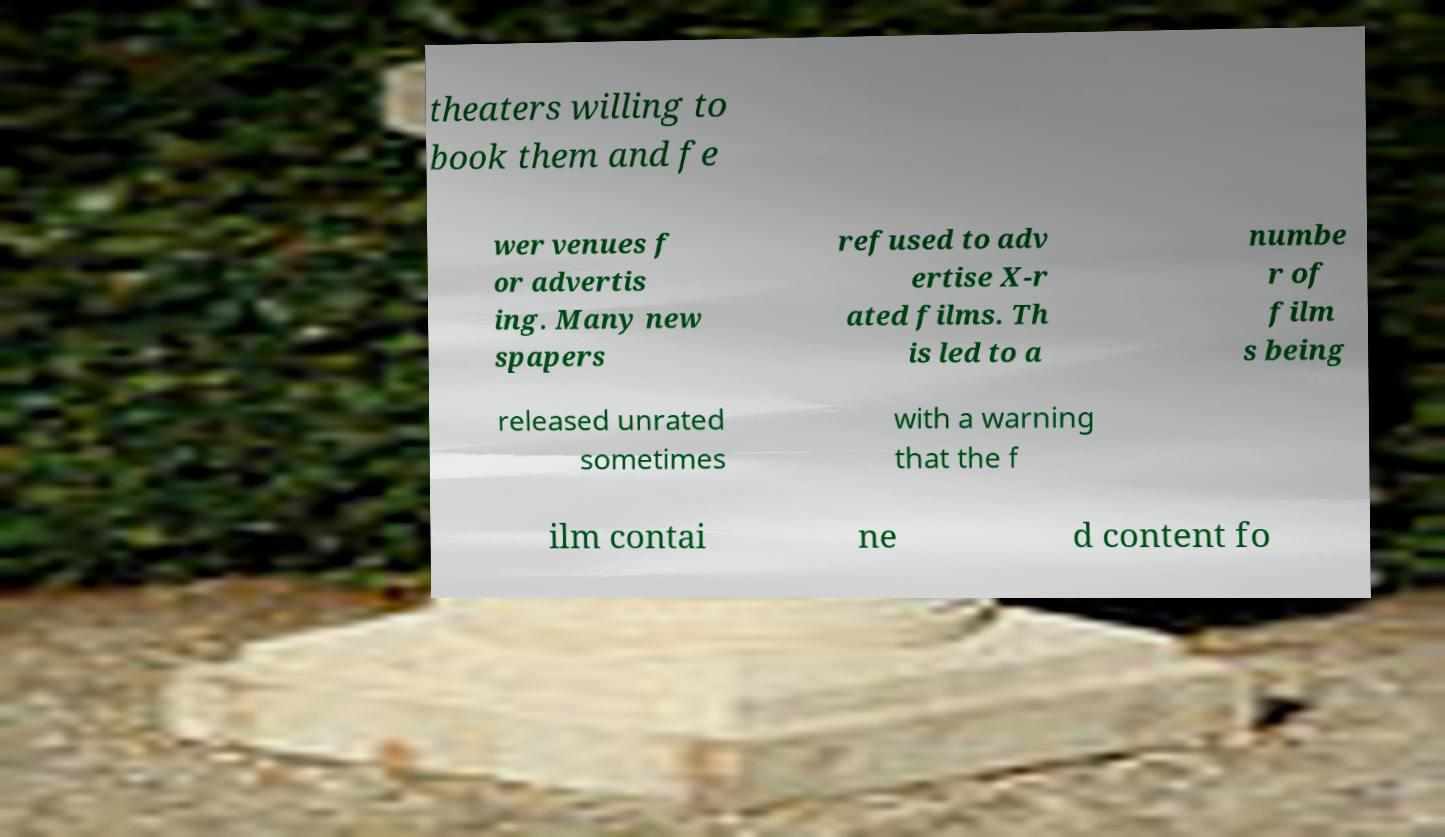Please identify and transcribe the text found in this image. theaters willing to book them and fe wer venues f or advertis ing. Many new spapers refused to adv ertise X-r ated films. Th is led to a numbe r of film s being released unrated sometimes with a warning that the f ilm contai ne d content fo 